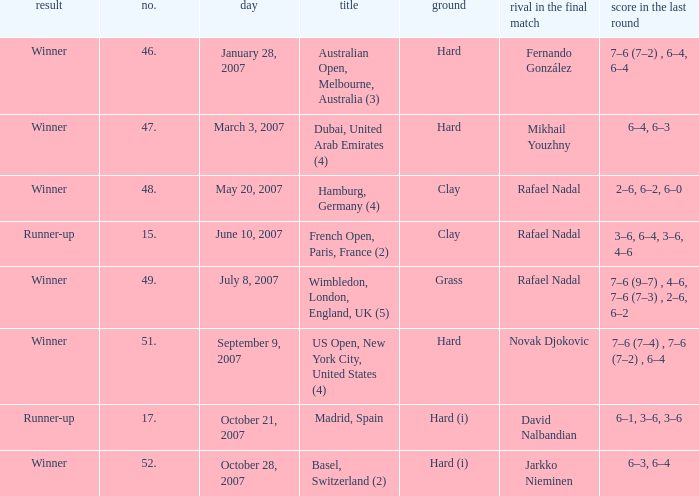With the final match resulting in scores of 2-6, 6-2, and 6-0, what was the surface? Clay. 